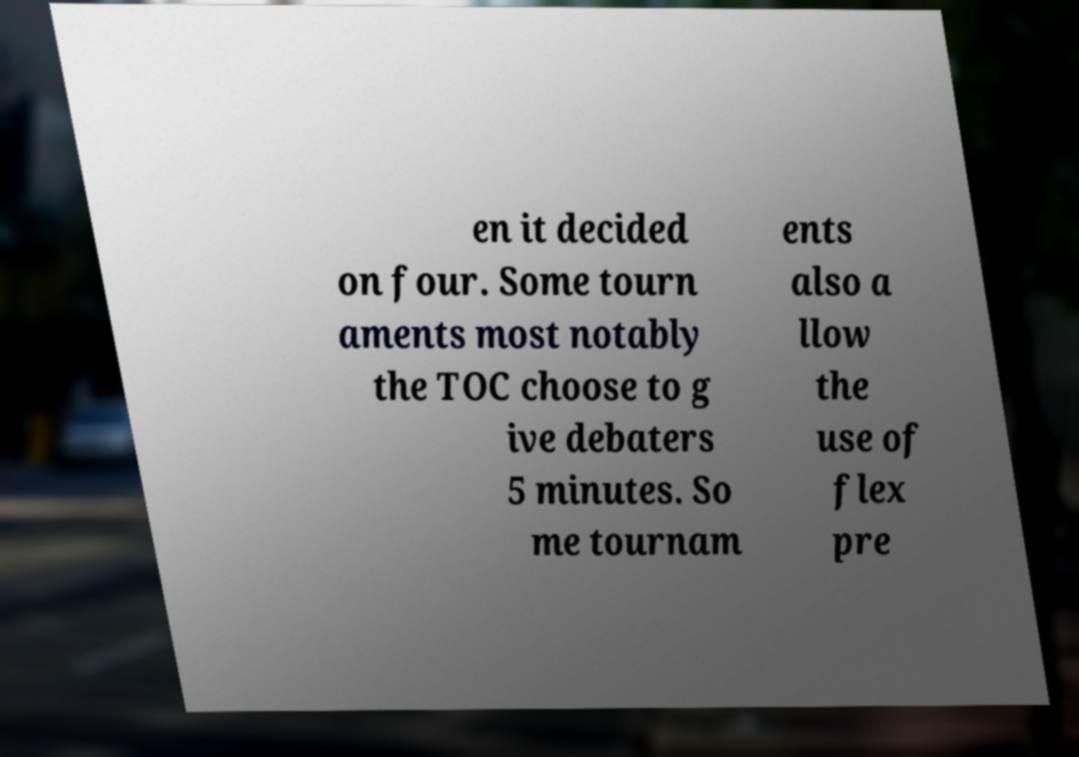There's text embedded in this image that I need extracted. Can you transcribe it verbatim? en it decided on four. Some tourn aments most notably the TOC choose to g ive debaters 5 minutes. So me tournam ents also a llow the use of flex pre 